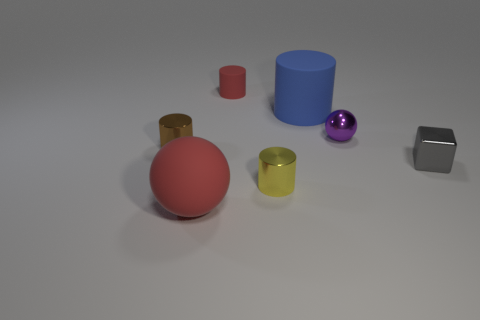Subtract all red matte cylinders. How many cylinders are left? 3 Subtract all blue cylinders. How many cylinders are left? 3 Subtract 1 cylinders. How many cylinders are left? 3 Add 2 gray shiny blocks. How many objects exist? 9 Subtract all balls. How many objects are left? 5 Subtract all yellow blocks. Subtract all gray spheres. How many blocks are left? 1 Subtract all large yellow metal objects. Subtract all red things. How many objects are left? 5 Add 6 big blue objects. How many big blue objects are left? 7 Add 4 tiny red matte objects. How many tiny red matte objects exist? 5 Subtract 1 gray cubes. How many objects are left? 6 